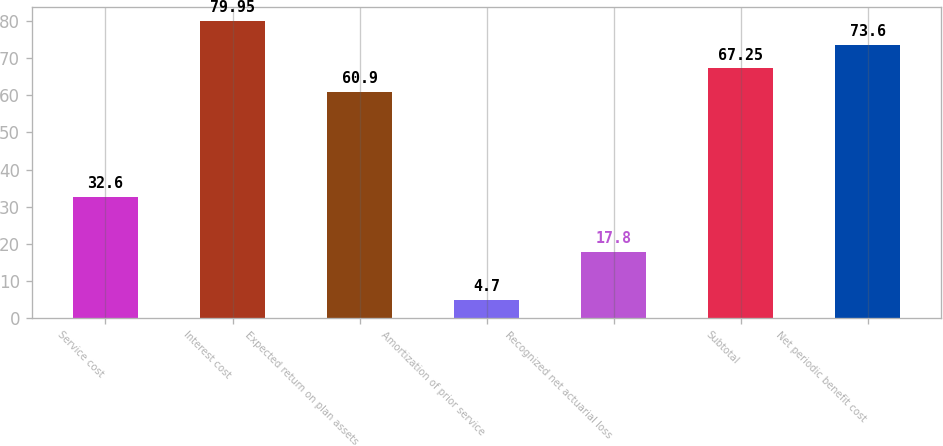Convert chart. <chart><loc_0><loc_0><loc_500><loc_500><bar_chart><fcel>Service cost<fcel>Interest cost<fcel>Expected return on plan assets<fcel>Amortization of prior service<fcel>Recognized net actuarial loss<fcel>Subtotal<fcel>Net periodic benefit cost<nl><fcel>32.6<fcel>79.95<fcel>60.9<fcel>4.7<fcel>17.8<fcel>67.25<fcel>73.6<nl></chart> 